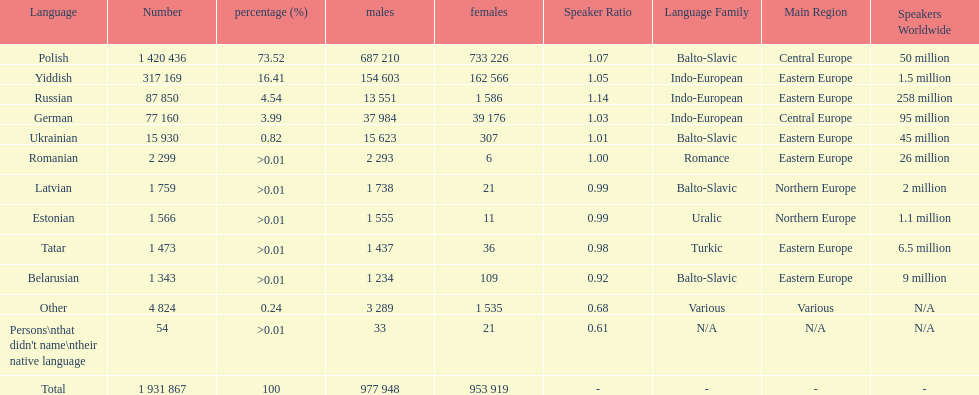Which language had the least female speakers? Romanian. 